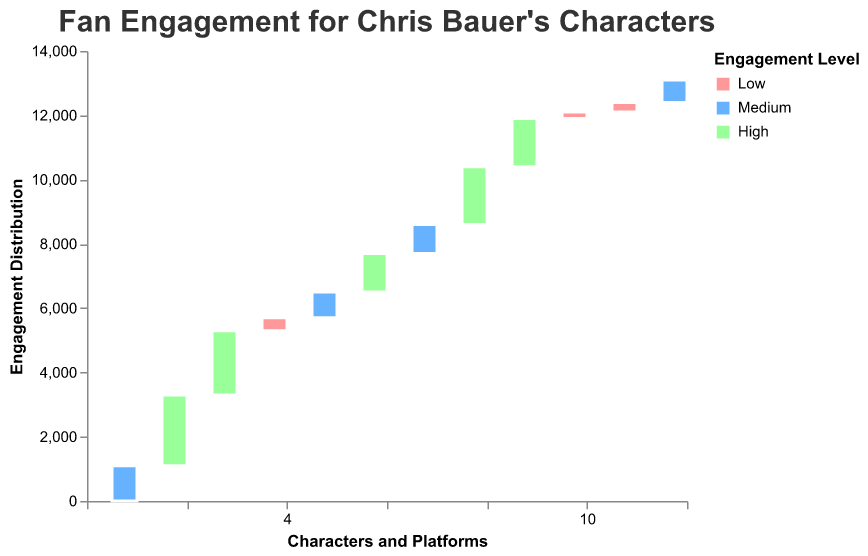What is the engagement level of "John Constantine" on Twitter? The engagement level of John Constantine on Twitter is indicated by the color representing "High" engagement in the plot.
Answer: High Which character has the highest engagement level consistently across all platforms? By examining the colors representing the engagement levels across all platforms for each character, you will notice that "Dream of the Endless" has the highest engagement level ("High") consistently on Twitter, Instagram, and Facebook.
Answer: Dream of the Endless How does "Swamp Thing" perform in terms of engagement on Instagram compared to Facebook? The engagement level for Swamp Thing on Instagram is represented by the color corresponding to "Low". Similarly, the engagement level for Swamp Thing on Facebook is also "Low", as indicated by the same color in the plot.
Answer: Both Low What is the difference in "High" engagement count between "Lucifer Morningstar" on Instagram and "John Constantine" on Twitter? The count for "High" engagement on Instagram for Lucifer Morningstar is 1800. The count for "High" engagement on Twitter for John Constantine is 1200. The difference is 1800 - 1200.
Answer: 600 Which character achieves the highest engagement level on Facebook? By looking at the colors representing the engagement levels on Facebook, "Dream of the Endless" achieves the highest engagement level since the shade represents "Medium" and it's relatively higher in engagement.
Answer: Dream of the Endless What is the total engagement count for "Dream of the Endless" on all platforms? Summing up the counts for Dream of the Endless on each platform: Twitter (2000), Instagram (2200), and Facebook (1100), the total is 2000 + 2200 + 1100.
Answer: 5300 Who has higher engagement on Twitter, "John Constantine" or "Lucifer Morningstar"? By comparing the engagement levels on Twitter, both have a "High" engagement level, but "Lucifer Morningstar" has a count of 1500, which is higher than John Constantine's 1200.
Answer: Lucifer Morningstar What is the average engagement count for "Swamp Thing" across all platforms? Adding the counts for Swamp Thing across Twitter, Instagram, and Facebook (700 + 300 + 200) and dividing by the number of platforms (3), the average engagement count is (700 + 300 + 200)/3.
Answer: 400 Compare the overall engagement levels of "Lucifer Morningstar" on Twitter and Instagram. "Lucifer Morningstar" has "High" engagement on both Twitter and Instagram as shown by the corresponding colors in the plot. Since there is no substantial difference in engagement levels, they are considered similar.
Answer: Similar Which platform shows the greatest engagement level for "John Constantine"? By comparing the colors representing engagement levels for John Constantine on each platform, Twitter shows "High" engagement, which is greater than the "Medium" engagement level on Instagram and "Low" engagement on Facebook.
Answer: Twitter 